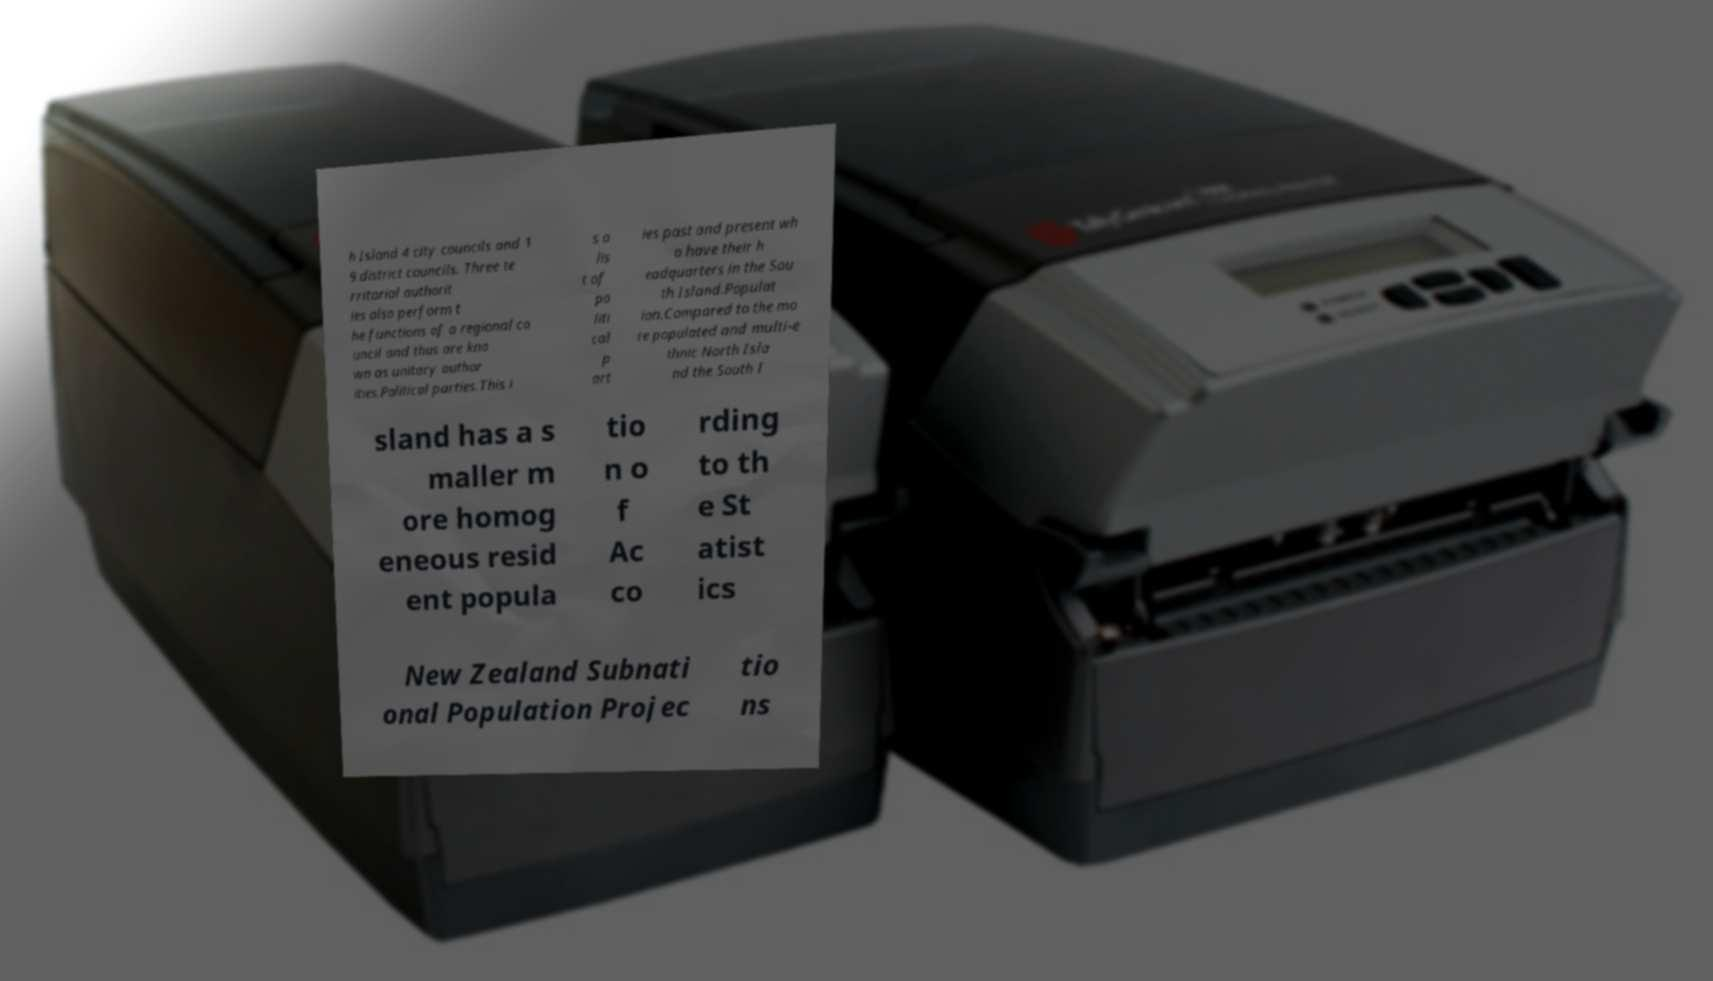Could you extract and type out the text from this image? h Island 4 city councils and 1 9 district councils. Three te rritorial authorit ies also perform t he functions of a regional co uncil and thus are kno wn as unitary author ities.Political parties.This i s a lis t of po liti cal p art ies past and present wh o have their h eadquarters in the Sou th Island.Populat ion.Compared to the mo re populated and multi-e thnic North Isla nd the South I sland has a s maller m ore homog eneous resid ent popula tio n o f Ac co rding to th e St atist ics New Zealand Subnati onal Population Projec tio ns 